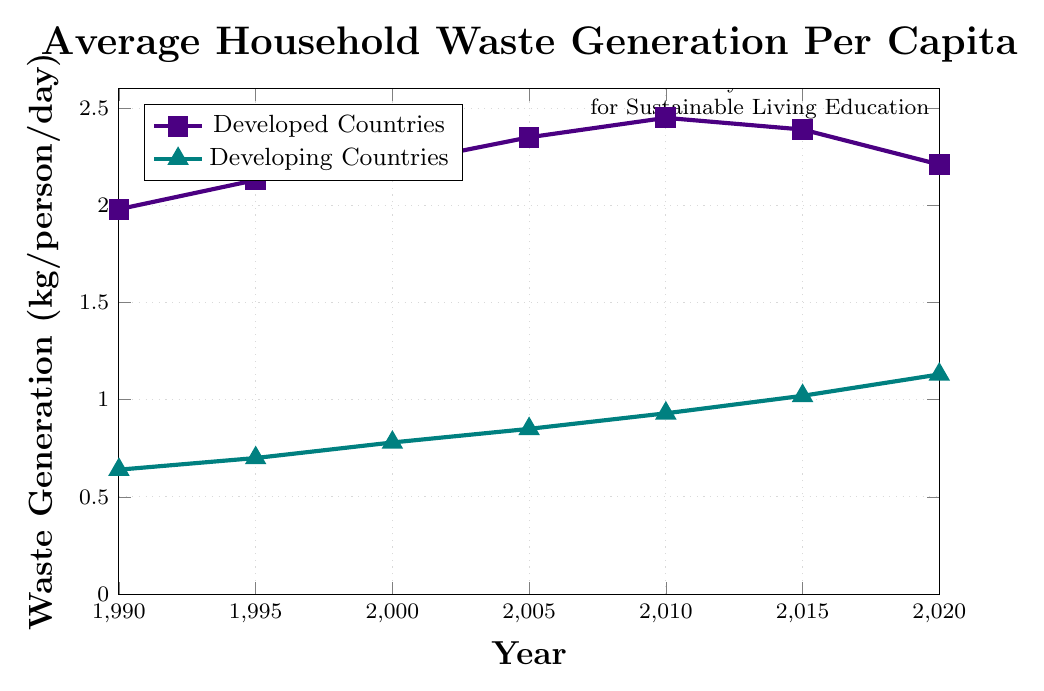what was the waste generation in developing countries in the year 2000? Look at the coordinate corresponding to the year 2000 on the line representing developing countries. It intersects at 0.78 kg/person/day.
Answer: 0.78 kg/person/day What is the maximum waste generation value for developed countries? Examine the line representing developed countries and find the highest point. The peak value is 2.45 kg/person/day in the year 2010.
Answer: 2.45 kg/person/day How did the waste generation in developed countries change between 1990 and 2020? Compare the values for developed countries in 1990 and 2020. The waste generation increased from 1.98 kg/person/day in 1990 to 2.45 kg/person/day in 2010 and then decreased to 2.21 kg/person/day in 2020.
Answer: Increased initially, then decreased Which year saw the largest difference in waste generation between developed and developing countries? Calculate the differences for each year and identify the highest. In 1990, the difference is 1.98 - 0.64 = 1.34 kg/person/day. 1995: 2.13 - 0.70 = 1.43, 2000: 2.21 - 0.78 = 1.43, 2005: 2.35 - 0.85 = 1.50, 2010: 2.45 - 0.93 = 1.52, 2015: 2.39 - 1.02 = 1.37, 2020: 2.21 - 1.13 = 1.08. The largest difference is in 2010 with 1.52 kg/person/day.
Answer: 2010 Which group had a more consistent increase in waste generation over the 30 years? Examine the trends for both groups. Developing countries show a consistent increase, while developed countries initially increase, peak, and then decrease.
Answer: Developing countries By how much did waste generation increase in developing countries from 1990 to 2020? Subtract the 1990 value for developing countries from the 2020 value: 1.13 - 0.64 = 0.49 kg/person/day.
Answer: 0.49 kg/person/day What is the general trend of waste generation in developed countries between 2010 and 2020? Identify the values for developed countries in 2010 and 2020; it starts at 2.45 kg/person/day in 2010 and drops to 2.21 kg/person/day in 2020.
Answer: Decreasing Which year did developing countries surpass 1 kg/person/day in waste generation? Locate the coordinate where the developing countries' value exceeds 1 kg/person/day. It is in 2015 with 1.02 kg/person/day.
Answer: 2015 How does the waste generation in developed countries in 2000 compare with developing countries in 2020? Compare the given values: in 2000, developed countries had 2.21 kg/person/day, and in 2020, developing countries had 1.13 kg/person/day.
Answer: Higher in 2000 for developed countries 